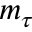Convert formula to latex. <formula><loc_0><loc_0><loc_500><loc_500>m _ { \tau }</formula> 